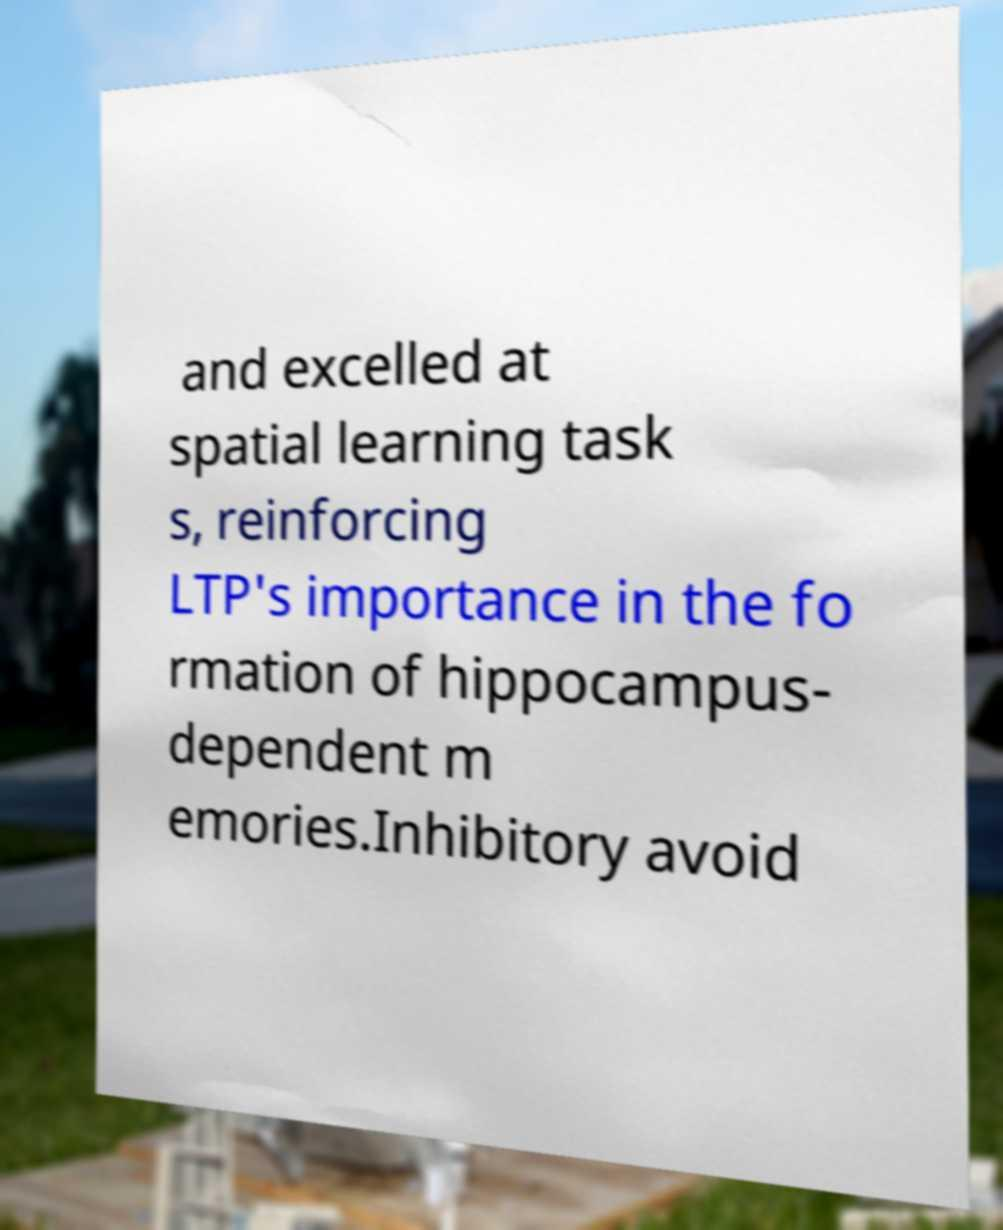Could you extract and type out the text from this image? and excelled at spatial learning task s, reinforcing LTP's importance in the fo rmation of hippocampus- dependent m emories.Inhibitory avoid 